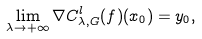Convert formula to latex. <formula><loc_0><loc_0><loc_500><loc_500>\lim _ { \lambda \to + \infty } \nabla C ^ { l } _ { \lambda , G } ( f ) ( x _ { 0 } ) = y _ { 0 } ,</formula> 